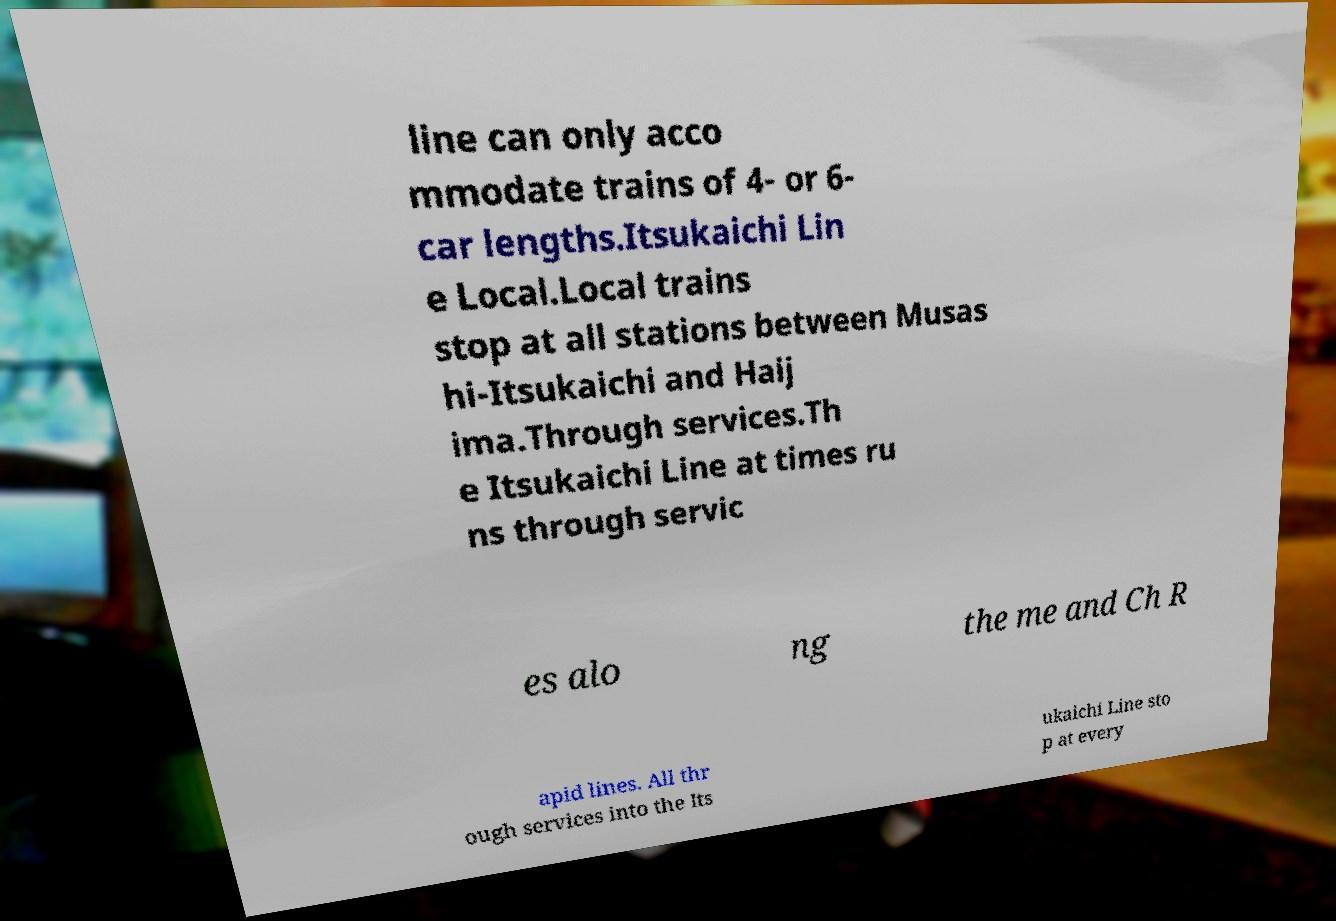What messages or text are displayed in this image? I need them in a readable, typed format. line can only acco mmodate trains of 4- or 6- car lengths.Itsukaichi Lin e Local.Local trains stop at all stations between Musas hi-Itsukaichi and Haij ima.Through services.Th e Itsukaichi Line at times ru ns through servic es alo ng the me and Ch R apid lines. All thr ough services into the Its ukaichi Line sto p at every 